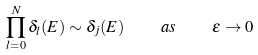Convert formula to latex. <formula><loc_0><loc_0><loc_500><loc_500>\prod _ { l = 0 } ^ { N } \delta _ { l } ( E ) \sim \delta _ { j } ( E ) \quad a s \quad \varepsilon \to 0</formula> 